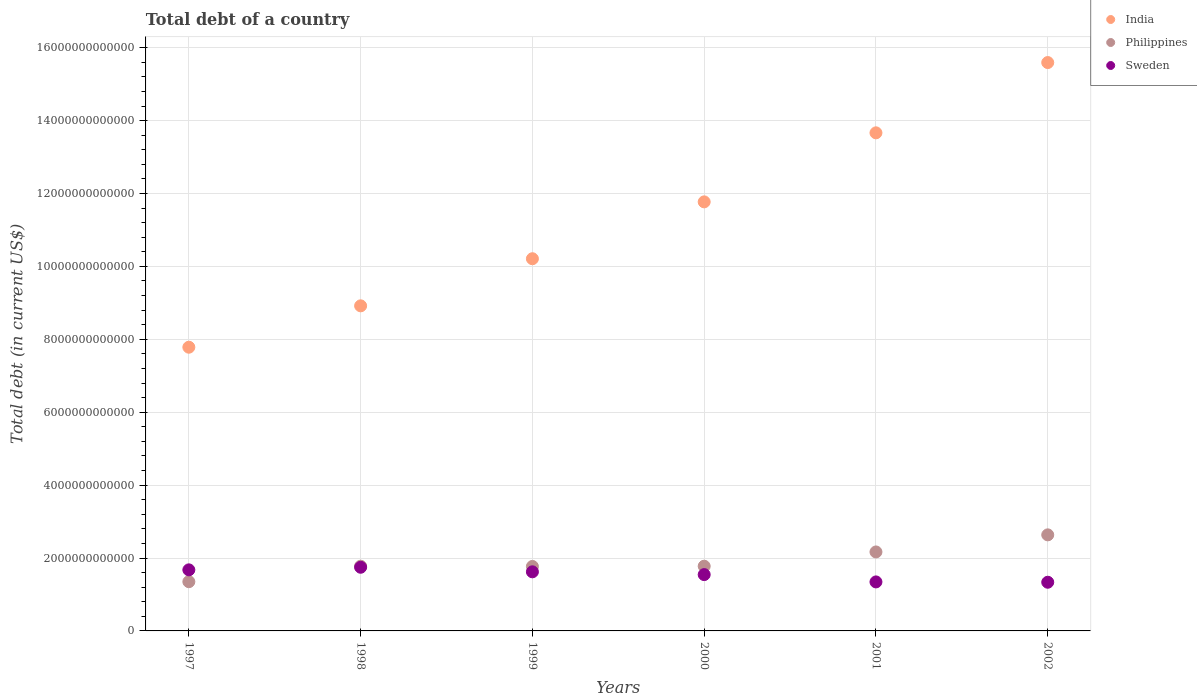How many different coloured dotlines are there?
Ensure brevity in your answer.  3. What is the debt in Sweden in 2002?
Ensure brevity in your answer.  1.34e+12. Across all years, what is the maximum debt in Sweden?
Give a very brief answer. 1.75e+12. Across all years, what is the minimum debt in India?
Make the answer very short. 7.78e+12. In which year was the debt in Sweden maximum?
Keep it short and to the point. 1998. In which year was the debt in Sweden minimum?
Your response must be concise. 2002. What is the total debt in Philippines in the graph?
Offer a very short reply. 1.15e+13. What is the difference between the debt in Philippines in 2001 and that in 2002?
Keep it short and to the point. -4.69e+11. What is the difference between the debt in Sweden in 1998 and the debt in India in 1997?
Give a very brief answer. -6.04e+12. What is the average debt in India per year?
Keep it short and to the point. 1.13e+13. In the year 2000, what is the difference between the debt in Philippines and debt in Sweden?
Make the answer very short. 2.30e+11. What is the ratio of the debt in Sweden in 1997 to that in 1998?
Ensure brevity in your answer.  0.96. What is the difference between the highest and the second highest debt in India?
Provide a succinct answer. 1.93e+12. What is the difference between the highest and the lowest debt in Sweden?
Provide a short and direct response. 4.11e+11. In how many years, is the debt in India greater than the average debt in India taken over all years?
Ensure brevity in your answer.  3. Is the sum of the debt in Philippines in 1998 and 2001 greater than the maximum debt in India across all years?
Your answer should be very brief. No. Is the debt in Sweden strictly less than the debt in India over the years?
Make the answer very short. Yes. How many dotlines are there?
Offer a very short reply. 3. What is the difference between two consecutive major ticks on the Y-axis?
Give a very brief answer. 2.00e+12. Are the values on the major ticks of Y-axis written in scientific E-notation?
Your answer should be very brief. No. Does the graph contain grids?
Your answer should be compact. Yes. Where does the legend appear in the graph?
Your response must be concise. Top right. How many legend labels are there?
Your response must be concise. 3. What is the title of the graph?
Your answer should be very brief. Total debt of a country. What is the label or title of the Y-axis?
Provide a succinct answer. Total debt (in current US$). What is the Total debt (in current US$) of India in 1997?
Provide a short and direct response. 7.78e+12. What is the Total debt (in current US$) in Philippines in 1997?
Your answer should be very brief. 1.35e+12. What is the Total debt (in current US$) in Sweden in 1997?
Your response must be concise. 1.68e+12. What is the Total debt (in current US$) of India in 1998?
Offer a terse response. 8.92e+12. What is the Total debt (in current US$) in Philippines in 1998?
Offer a very short reply. 1.78e+12. What is the Total debt (in current US$) of Sweden in 1998?
Your answer should be very brief. 1.75e+12. What is the Total debt (in current US$) of India in 1999?
Your response must be concise. 1.02e+13. What is the Total debt (in current US$) in Philippines in 1999?
Offer a very short reply. 1.77e+12. What is the Total debt (in current US$) of Sweden in 1999?
Your response must be concise. 1.62e+12. What is the Total debt (in current US$) of India in 2000?
Make the answer very short. 1.18e+13. What is the Total debt (in current US$) of Philippines in 2000?
Your answer should be very brief. 1.78e+12. What is the Total debt (in current US$) of Sweden in 2000?
Your answer should be compact. 1.54e+12. What is the Total debt (in current US$) in India in 2001?
Ensure brevity in your answer.  1.37e+13. What is the Total debt (in current US$) in Philippines in 2001?
Ensure brevity in your answer.  2.17e+12. What is the Total debt (in current US$) in Sweden in 2001?
Offer a very short reply. 1.34e+12. What is the Total debt (in current US$) of India in 2002?
Provide a short and direct response. 1.56e+13. What is the Total debt (in current US$) of Philippines in 2002?
Ensure brevity in your answer.  2.64e+12. What is the Total debt (in current US$) in Sweden in 2002?
Provide a short and direct response. 1.34e+12. Across all years, what is the maximum Total debt (in current US$) in India?
Your answer should be compact. 1.56e+13. Across all years, what is the maximum Total debt (in current US$) of Philippines?
Provide a succinct answer. 2.64e+12. Across all years, what is the maximum Total debt (in current US$) in Sweden?
Give a very brief answer. 1.75e+12. Across all years, what is the minimum Total debt (in current US$) of India?
Keep it short and to the point. 7.78e+12. Across all years, what is the minimum Total debt (in current US$) of Philippines?
Your answer should be very brief. 1.35e+12. Across all years, what is the minimum Total debt (in current US$) in Sweden?
Provide a succinct answer. 1.34e+12. What is the total Total debt (in current US$) of India in the graph?
Ensure brevity in your answer.  6.79e+13. What is the total Total debt (in current US$) of Philippines in the graph?
Ensure brevity in your answer.  1.15e+13. What is the total Total debt (in current US$) in Sweden in the graph?
Keep it short and to the point. 9.27e+12. What is the difference between the Total debt (in current US$) in India in 1997 and that in 1998?
Your answer should be compact. -1.14e+12. What is the difference between the Total debt (in current US$) in Philippines in 1997 and that in 1998?
Your answer should be very brief. -4.25e+11. What is the difference between the Total debt (in current US$) in Sweden in 1997 and that in 1998?
Offer a terse response. -7.13e+1. What is the difference between the Total debt (in current US$) of India in 1997 and that in 1999?
Offer a very short reply. -2.43e+12. What is the difference between the Total debt (in current US$) in Philippines in 1997 and that in 1999?
Offer a very short reply. -4.18e+11. What is the difference between the Total debt (in current US$) of Sweden in 1997 and that in 1999?
Offer a very short reply. 5.41e+1. What is the difference between the Total debt (in current US$) of India in 1997 and that in 2000?
Provide a short and direct response. -3.99e+12. What is the difference between the Total debt (in current US$) in Philippines in 1997 and that in 2000?
Offer a very short reply. -4.25e+11. What is the difference between the Total debt (in current US$) in Sweden in 1997 and that in 2000?
Make the answer very short. 1.30e+11. What is the difference between the Total debt (in current US$) of India in 1997 and that in 2001?
Ensure brevity in your answer.  -5.88e+12. What is the difference between the Total debt (in current US$) of Philippines in 1997 and that in 2001?
Give a very brief answer. -8.16e+11. What is the difference between the Total debt (in current US$) in Sweden in 1997 and that in 2001?
Your answer should be compact. 3.31e+11. What is the difference between the Total debt (in current US$) of India in 1997 and that in 2002?
Offer a terse response. -7.81e+12. What is the difference between the Total debt (in current US$) in Philippines in 1997 and that in 2002?
Provide a short and direct response. -1.28e+12. What is the difference between the Total debt (in current US$) in Sweden in 1997 and that in 2002?
Offer a terse response. 3.40e+11. What is the difference between the Total debt (in current US$) of India in 1998 and that in 1999?
Provide a succinct answer. -1.29e+12. What is the difference between the Total debt (in current US$) of Philippines in 1998 and that in 1999?
Your response must be concise. 6.66e+09. What is the difference between the Total debt (in current US$) in Sweden in 1998 and that in 1999?
Offer a terse response. 1.25e+11. What is the difference between the Total debt (in current US$) in India in 1998 and that in 2000?
Your response must be concise. -2.85e+12. What is the difference between the Total debt (in current US$) in Philippines in 1998 and that in 2000?
Ensure brevity in your answer.  0. What is the difference between the Total debt (in current US$) of Sweden in 1998 and that in 2000?
Keep it short and to the point. 2.02e+11. What is the difference between the Total debt (in current US$) in India in 1998 and that in 2001?
Your answer should be very brief. -4.75e+12. What is the difference between the Total debt (in current US$) of Philippines in 1998 and that in 2001?
Provide a short and direct response. -3.91e+11. What is the difference between the Total debt (in current US$) of Sweden in 1998 and that in 2001?
Ensure brevity in your answer.  4.02e+11. What is the difference between the Total debt (in current US$) in India in 1998 and that in 2002?
Offer a very short reply. -6.67e+12. What is the difference between the Total debt (in current US$) of Philippines in 1998 and that in 2002?
Provide a short and direct response. -8.60e+11. What is the difference between the Total debt (in current US$) in Sweden in 1998 and that in 2002?
Keep it short and to the point. 4.11e+11. What is the difference between the Total debt (in current US$) of India in 1999 and that in 2000?
Keep it short and to the point. -1.56e+12. What is the difference between the Total debt (in current US$) in Philippines in 1999 and that in 2000?
Offer a terse response. -6.66e+09. What is the difference between the Total debt (in current US$) of Sweden in 1999 and that in 2000?
Your response must be concise. 7.62e+1. What is the difference between the Total debt (in current US$) in India in 1999 and that in 2001?
Provide a succinct answer. -3.45e+12. What is the difference between the Total debt (in current US$) in Philippines in 1999 and that in 2001?
Give a very brief answer. -3.98e+11. What is the difference between the Total debt (in current US$) of Sweden in 1999 and that in 2001?
Your answer should be very brief. 2.77e+11. What is the difference between the Total debt (in current US$) of India in 1999 and that in 2002?
Keep it short and to the point. -5.38e+12. What is the difference between the Total debt (in current US$) of Philippines in 1999 and that in 2002?
Your response must be concise. -8.67e+11. What is the difference between the Total debt (in current US$) in Sweden in 1999 and that in 2002?
Offer a terse response. 2.86e+11. What is the difference between the Total debt (in current US$) of India in 2000 and that in 2001?
Offer a very short reply. -1.89e+12. What is the difference between the Total debt (in current US$) of Philippines in 2000 and that in 2001?
Make the answer very short. -3.91e+11. What is the difference between the Total debt (in current US$) in Sweden in 2000 and that in 2001?
Give a very brief answer. 2.01e+11. What is the difference between the Total debt (in current US$) in India in 2000 and that in 2002?
Make the answer very short. -3.82e+12. What is the difference between the Total debt (in current US$) in Philippines in 2000 and that in 2002?
Give a very brief answer. -8.60e+11. What is the difference between the Total debt (in current US$) of Sweden in 2000 and that in 2002?
Offer a very short reply. 2.10e+11. What is the difference between the Total debt (in current US$) in India in 2001 and that in 2002?
Provide a short and direct response. -1.93e+12. What is the difference between the Total debt (in current US$) of Philippines in 2001 and that in 2002?
Make the answer very short. -4.69e+11. What is the difference between the Total debt (in current US$) of Sweden in 2001 and that in 2002?
Your response must be concise. 8.93e+09. What is the difference between the Total debt (in current US$) in India in 1997 and the Total debt (in current US$) in Philippines in 1998?
Offer a very short reply. 6.01e+12. What is the difference between the Total debt (in current US$) in India in 1997 and the Total debt (in current US$) in Sweden in 1998?
Offer a terse response. 6.04e+12. What is the difference between the Total debt (in current US$) of Philippines in 1997 and the Total debt (in current US$) of Sweden in 1998?
Keep it short and to the point. -3.96e+11. What is the difference between the Total debt (in current US$) in India in 1997 and the Total debt (in current US$) in Philippines in 1999?
Your response must be concise. 6.01e+12. What is the difference between the Total debt (in current US$) in India in 1997 and the Total debt (in current US$) in Sweden in 1999?
Provide a short and direct response. 6.16e+12. What is the difference between the Total debt (in current US$) in Philippines in 1997 and the Total debt (in current US$) in Sweden in 1999?
Provide a succinct answer. -2.71e+11. What is the difference between the Total debt (in current US$) of India in 1997 and the Total debt (in current US$) of Philippines in 2000?
Your answer should be very brief. 6.01e+12. What is the difference between the Total debt (in current US$) in India in 1997 and the Total debt (in current US$) in Sweden in 2000?
Give a very brief answer. 6.24e+12. What is the difference between the Total debt (in current US$) in Philippines in 1997 and the Total debt (in current US$) in Sweden in 2000?
Your answer should be very brief. -1.94e+11. What is the difference between the Total debt (in current US$) in India in 1997 and the Total debt (in current US$) in Philippines in 2001?
Offer a very short reply. 5.62e+12. What is the difference between the Total debt (in current US$) in India in 1997 and the Total debt (in current US$) in Sweden in 2001?
Your answer should be very brief. 6.44e+12. What is the difference between the Total debt (in current US$) in Philippines in 1997 and the Total debt (in current US$) in Sweden in 2001?
Keep it short and to the point. 6.17e+09. What is the difference between the Total debt (in current US$) of India in 1997 and the Total debt (in current US$) of Philippines in 2002?
Your answer should be compact. 5.15e+12. What is the difference between the Total debt (in current US$) in India in 1997 and the Total debt (in current US$) in Sweden in 2002?
Keep it short and to the point. 6.45e+12. What is the difference between the Total debt (in current US$) in Philippines in 1997 and the Total debt (in current US$) in Sweden in 2002?
Give a very brief answer. 1.51e+1. What is the difference between the Total debt (in current US$) in India in 1998 and the Total debt (in current US$) in Philippines in 1999?
Your response must be concise. 7.15e+12. What is the difference between the Total debt (in current US$) in India in 1998 and the Total debt (in current US$) in Sweden in 1999?
Make the answer very short. 7.30e+12. What is the difference between the Total debt (in current US$) in Philippines in 1998 and the Total debt (in current US$) in Sweden in 1999?
Your answer should be very brief. 1.54e+11. What is the difference between the Total debt (in current US$) of India in 1998 and the Total debt (in current US$) of Philippines in 2000?
Offer a terse response. 7.14e+12. What is the difference between the Total debt (in current US$) in India in 1998 and the Total debt (in current US$) in Sweden in 2000?
Your response must be concise. 7.37e+12. What is the difference between the Total debt (in current US$) of Philippines in 1998 and the Total debt (in current US$) of Sweden in 2000?
Your response must be concise. 2.30e+11. What is the difference between the Total debt (in current US$) in India in 1998 and the Total debt (in current US$) in Philippines in 2001?
Offer a very short reply. 6.75e+12. What is the difference between the Total debt (in current US$) in India in 1998 and the Total debt (in current US$) in Sweden in 2001?
Provide a succinct answer. 7.57e+12. What is the difference between the Total debt (in current US$) of Philippines in 1998 and the Total debt (in current US$) of Sweden in 2001?
Ensure brevity in your answer.  4.31e+11. What is the difference between the Total debt (in current US$) in India in 1998 and the Total debt (in current US$) in Philippines in 2002?
Provide a succinct answer. 6.28e+12. What is the difference between the Total debt (in current US$) of India in 1998 and the Total debt (in current US$) of Sweden in 2002?
Ensure brevity in your answer.  7.58e+12. What is the difference between the Total debt (in current US$) of Philippines in 1998 and the Total debt (in current US$) of Sweden in 2002?
Keep it short and to the point. 4.40e+11. What is the difference between the Total debt (in current US$) of India in 1999 and the Total debt (in current US$) of Philippines in 2000?
Your answer should be compact. 8.43e+12. What is the difference between the Total debt (in current US$) of India in 1999 and the Total debt (in current US$) of Sweden in 2000?
Provide a succinct answer. 8.67e+12. What is the difference between the Total debt (in current US$) in Philippines in 1999 and the Total debt (in current US$) in Sweden in 2000?
Provide a short and direct response. 2.24e+11. What is the difference between the Total debt (in current US$) of India in 1999 and the Total debt (in current US$) of Philippines in 2001?
Provide a short and direct response. 8.04e+12. What is the difference between the Total debt (in current US$) in India in 1999 and the Total debt (in current US$) in Sweden in 2001?
Provide a succinct answer. 8.87e+12. What is the difference between the Total debt (in current US$) of Philippines in 1999 and the Total debt (in current US$) of Sweden in 2001?
Offer a very short reply. 4.24e+11. What is the difference between the Total debt (in current US$) in India in 1999 and the Total debt (in current US$) in Philippines in 2002?
Your answer should be very brief. 7.58e+12. What is the difference between the Total debt (in current US$) of India in 1999 and the Total debt (in current US$) of Sweden in 2002?
Your answer should be compact. 8.87e+12. What is the difference between the Total debt (in current US$) in Philippines in 1999 and the Total debt (in current US$) in Sweden in 2002?
Provide a succinct answer. 4.33e+11. What is the difference between the Total debt (in current US$) in India in 2000 and the Total debt (in current US$) in Philippines in 2001?
Offer a terse response. 9.60e+12. What is the difference between the Total debt (in current US$) of India in 2000 and the Total debt (in current US$) of Sweden in 2001?
Keep it short and to the point. 1.04e+13. What is the difference between the Total debt (in current US$) in Philippines in 2000 and the Total debt (in current US$) in Sweden in 2001?
Your answer should be compact. 4.31e+11. What is the difference between the Total debt (in current US$) of India in 2000 and the Total debt (in current US$) of Philippines in 2002?
Make the answer very short. 9.13e+12. What is the difference between the Total debt (in current US$) in India in 2000 and the Total debt (in current US$) in Sweden in 2002?
Ensure brevity in your answer.  1.04e+13. What is the difference between the Total debt (in current US$) of Philippines in 2000 and the Total debt (in current US$) of Sweden in 2002?
Your answer should be very brief. 4.40e+11. What is the difference between the Total debt (in current US$) in India in 2001 and the Total debt (in current US$) in Philippines in 2002?
Keep it short and to the point. 1.10e+13. What is the difference between the Total debt (in current US$) in India in 2001 and the Total debt (in current US$) in Sweden in 2002?
Your answer should be very brief. 1.23e+13. What is the difference between the Total debt (in current US$) in Philippines in 2001 and the Total debt (in current US$) in Sweden in 2002?
Provide a short and direct response. 8.31e+11. What is the average Total debt (in current US$) in India per year?
Offer a terse response. 1.13e+13. What is the average Total debt (in current US$) of Philippines per year?
Provide a succinct answer. 1.91e+12. What is the average Total debt (in current US$) in Sweden per year?
Make the answer very short. 1.54e+12. In the year 1997, what is the difference between the Total debt (in current US$) in India and Total debt (in current US$) in Philippines?
Keep it short and to the point. 6.43e+12. In the year 1997, what is the difference between the Total debt (in current US$) of India and Total debt (in current US$) of Sweden?
Your response must be concise. 6.11e+12. In the year 1997, what is the difference between the Total debt (in current US$) of Philippines and Total debt (in current US$) of Sweden?
Give a very brief answer. -3.25e+11. In the year 1998, what is the difference between the Total debt (in current US$) of India and Total debt (in current US$) of Philippines?
Provide a short and direct response. 7.14e+12. In the year 1998, what is the difference between the Total debt (in current US$) in India and Total debt (in current US$) in Sweden?
Provide a short and direct response. 7.17e+12. In the year 1998, what is the difference between the Total debt (in current US$) of Philippines and Total debt (in current US$) of Sweden?
Give a very brief answer. 2.88e+1. In the year 1999, what is the difference between the Total debt (in current US$) in India and Total debt (in current US$) in Philippines?
Your response must be concise. 8.44e+12. In the year 1999, what is the difference between the Total debt (in current US$) in India and Total debt (in current US$) in Sweden?
Your response must be concise. 8.59e+12. In the year 1999, what is the difference between the Total debt (in current US$) of Philippines and Total debt (in current US$) of Sweden?
Give a very brief answer. 1.47e+11. In the year 2000, what is the difference between the Total debt (in current US$) of India and Total debt (in current US$) of Philippines?
Your answer should be very brief. 9.99e+12. In the year 2000, what is the difference between the Total debt (in current US$) of India and Total debt (in current US$) of Sweden?
Offer a terse response. 1.02e+13. In the year 2000, what is the difference between the Total debt (in current US$) in Philippines and Total debt (in current US$) in Sweden?
Your answer should be compact. 2.30e+11. In the year 2001, what is the difference between the Total debt (in current US$) in India and Total debt (in current US$) in Philippines?
Your response must be concise. 1.15e+13. In the year 2001, what is the difference between the Total debt (in current US$) of India and Total debt (in current US$) of Sweden?
Your answer should be very brief. 1.23e+13. In the year 2001, what is the difference between the Total debt (in current US$) in Philippines and Total debt (in current US$) in Sweden?
Offer a terse response. 8.22e+11. In the year 2002, what is the difference between the Total debt (in current US$) in India and Total debt (in current US$) in Philippines?
Your answer should be compact. 1.30e+13. In the year 2002, what is the difference between the Total debt (in current US$) of India and Total debt (in current US$) of Sweden?
Provide a short and direct response. 1.43e+13. In the year 2002, what is the difference between the Total debt (in current US$) of Philippines and Total debt (in current US$) of Sweden?
Your response must be concise. 1.30e+12. What is the ratio of the Total debt (in current US$) of India in 1997 to that in 1998?
Your answer should be very brief. 0.87. What is the ratio of the Total debt (in current US$) in Philippines in 1997 to that in 1998?
Make the answer very short. 0.76. What is the ratio of the Total debt (in current US$) in Sweden in 1997 to that in 1998?
Provide a short and direct response. 0.96. What is the ratio of the Total debt (in current US$) of India in 1997 to that in 1999?
Keep it short and to the point. 0.76. What is the ratio of the Total debt (in current US$) of Philippines in 1997 to that in 1999?
Offer a terse response. 0.76. What is the ratio of the Total debt (in current US$) in Sweden in 1997 to that in 1999?
Give a very brief answer. 1.03. What is the ratio of the Total debt (in current US$) in India in 1997 to that in 2000?
Offer a very short reply. 0.66. What is the ratio of the Total debt (in current US$) in Philippines in 1997 to that in 2000?
Your answer should be very brief. 0.76. What is the ratio of the Total debt (in current US$) in Sweden in 1997 to that in 2000?
Provide a succinct answer. 1.08. What is the ratio of the Total debt (in current US$) of India in 1997 to that in 2001?
Give a very brief answer. 0.57. What is the ratio of the Total debt (in current US$) of Philippines in 1997 to that in 2001?
Your answer should be compact. 0.62. What is the ratio of the Total debt (in current US$) in Sweden in 1997 to that in 2001?
Offer a very short reply. 1.25. What is the ratio of the Total debt (in current US$) in India in 1997 to that in 2002?
Ensure brevity in your answer.  0.5. What is the ratio of the Total debt (in current US$) of Philippines in 1997 to that in 2002?
Offer a terse response. 0.51. What is the ratio of the Total debt (in current US$) of Sweden in 1997 to that in 2002?
Make the answer very short. 1.25. What is the ratio of the Total debt (in current US$) of India in 1998 to that in 1999?
Give a very brief answer. 0.87. What is the ratio of the Total debt (in current US$) in Sweden in 1998 to that in 1999?
Provide a short and direct response. 1.08. What is the ratio of the Total debt (in current US$) of India in 1998 to that in 2000?
Offer a very short reply. 0.76. What is the ratio of the Total debt (in current US$) of Sweden in 1998 to that in 2000?
Provide a short and direct response. 1.13. What is the ratio of the Total debt (in current US$) in India in 1998 to that in 2001?
Provide a succinct answer. 0.65. What is the ratio of the Total debt (in current US$) of Philippines in 1998 to that in 2001?
Offer a very short reply. 0.82. What is the ratio of the Total debt (in current US$) of Sweden in 1998 to that in 2001?
Offer a very short reply. 1.3. What is the ratio of the Total debt (in current US$) in India in 1998 to that in 2002?
Provide a short and direct response. 0.57. What is the ratio of the Total debt (in current US$) in Philippines in 1998 to that in 2002?
Offer a very short reply. 0.67. What is the ratio of the Total debt (in current US$) of Sweden in 1998 to that in 2002?
Offer a terse response. 1.31. What is the ratio of the Total debt (in current US$) in India in 1999 to that in 2000?
Offer a very short reply. 0.87. What is the ratio of the Total debt (in current US$) of Philippines in 1999 to that in 2000?
Offer a very short reply. 1. What is the ratio of the Total debt (in current US$) of Sweden in 1999 to that in 2000?
Provide a short and direct response. 1.05. What is the ratio of the Total debt (in current US$) in India in 1999 to that in 2001?
Keep it short and to the point. 0.75. What is the ratio of the Total debt (in current US$) in Philippines in 1999 to that in 2001?
Make the answer very short. 0.82. What is the ratio of the Total debt (in current US$) in Sweden in 1999 to that in 2001?
Provide a succinct answer. 1.21. What is the ratio of the Total debt (in current US$) in India in 1999 to that in 2002?
Your answer should be very brief. 0.65. What is the ratio of the Total debt (in current US$) in Philippines in 1999 to that in 2002?
Provide a succinct answer. 0.67. What is the ratio of the Total debt (in current US$) in Sweden in 1999 to that in 2002?
Provide a succinct answer. 1.21. What is the ratio of the Total debt (in current US$) of India in 2000 to that in 2001?
Provide a succinct answer. 0.86. What is the ratio of the Total debt (in current US$) in Philippines in 2000 to that in 2001?
Offer a very short reply. 0.82. What is the ratio of the Total debt (in current US$) in Sweden in 2000 to that in 2001?
Your response must be concise. 1.15. What is the ratio of the Total debt (in current US$) of India in 2000 to that in 2002?
Make the answer very short. 0.75. What is the ratio of the Total debt (in current US$) in Philippines in 2000 to that in 2002?
Your response must be concise. 0.67. What is the ratio of the Total debt (in current US$) of Sweden in 2000 to that in 2002?
Ensure brevity in your answer.  1.16. What is the ratio of the Total debt (in current US$) in India in 2001 to that in 2002?
Your answer should be very brief. 0.88. What is the ratio of the Total debt (in current US$) in Philippines in 2001 to that in 2002?
Offer a terse response. 0.82. What is the difference between the highest and the second highest Total debt (in current US$) of India?
Your answer should be compact. 1.93e+12. What is the difference between the highest and the second highest Total debt (in current US$) in Philippines?
Make the answer very short. 4.69e+11. What is the difference between the highest and the second highest Total debt (in current US$) in Sweden?
Give a very brief answer. 7.13e+1. What is the difference between the highest and the lowest Total debt (in current US$) of India?
Provide a short and direct response. 7.81e+12. What is the difference between the highest and the lowest Total debt (in current US$) in Philippines?
Ensure brevity in your answer.  1.28e+12. What is the difference between the highest and the lowest Total debt (in current US$) in Sweden?
Provide a succinct answer. 4.11e+11. 